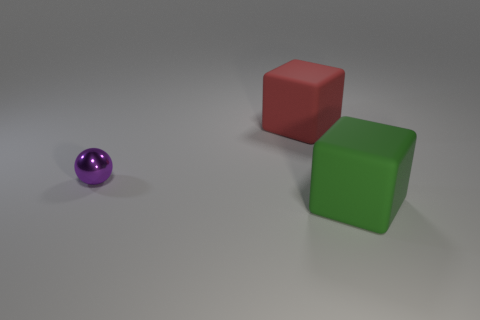Add 3 metallic objects. How many objects exist? 6 Subtract all cubes. How many objects are left? 1 Subtract 0 cyan balls. How many objects are left? 3 Subtract all small metallic balls. Subtract all small objects. How many objects are left? 1 Add 1 spheres. How many spheres are left? 2 Add 3 large blue cylinders. How many large blue cylinders exist? 3 